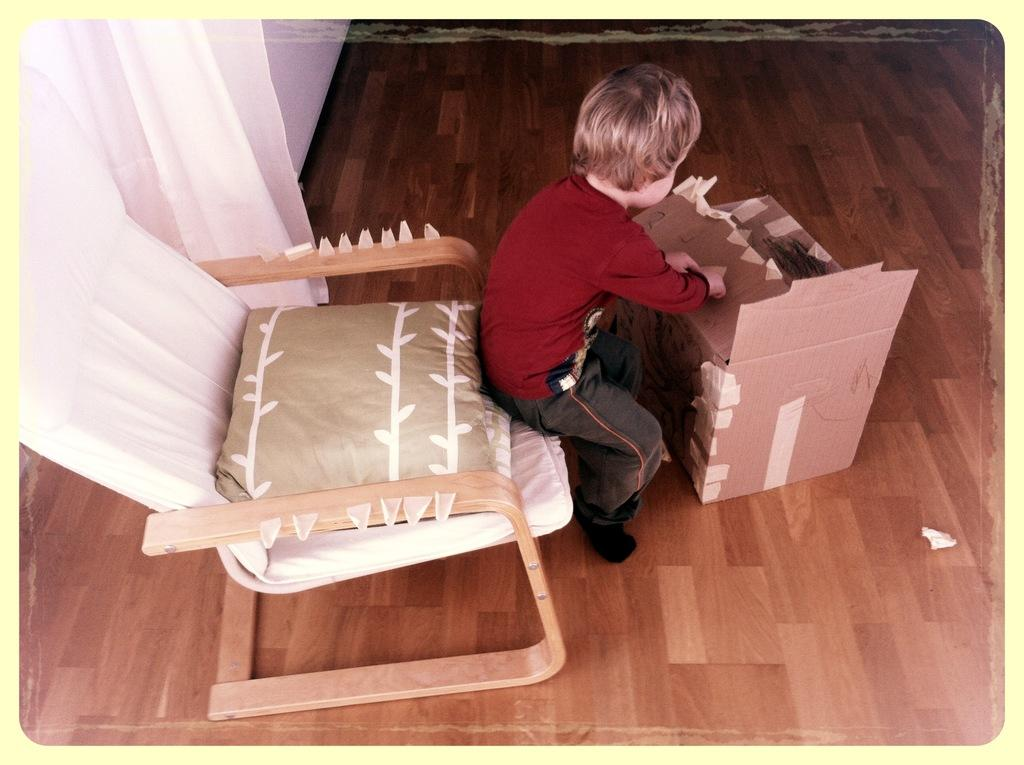What is the boy doing in the image? The boy is sitting on a chair in the image. What object is in front of the boy? There is a cardboard box in front of the boy. What type of covering can be seen in the image? There is a curtain visible in the image. What surface is the boy sitting on? The boy is sitting on a floor in the image. What type of pie is the boy holding in the image? There is no pie present in the image; the boy is sitting on a chair with a cardboard box in front of him. 